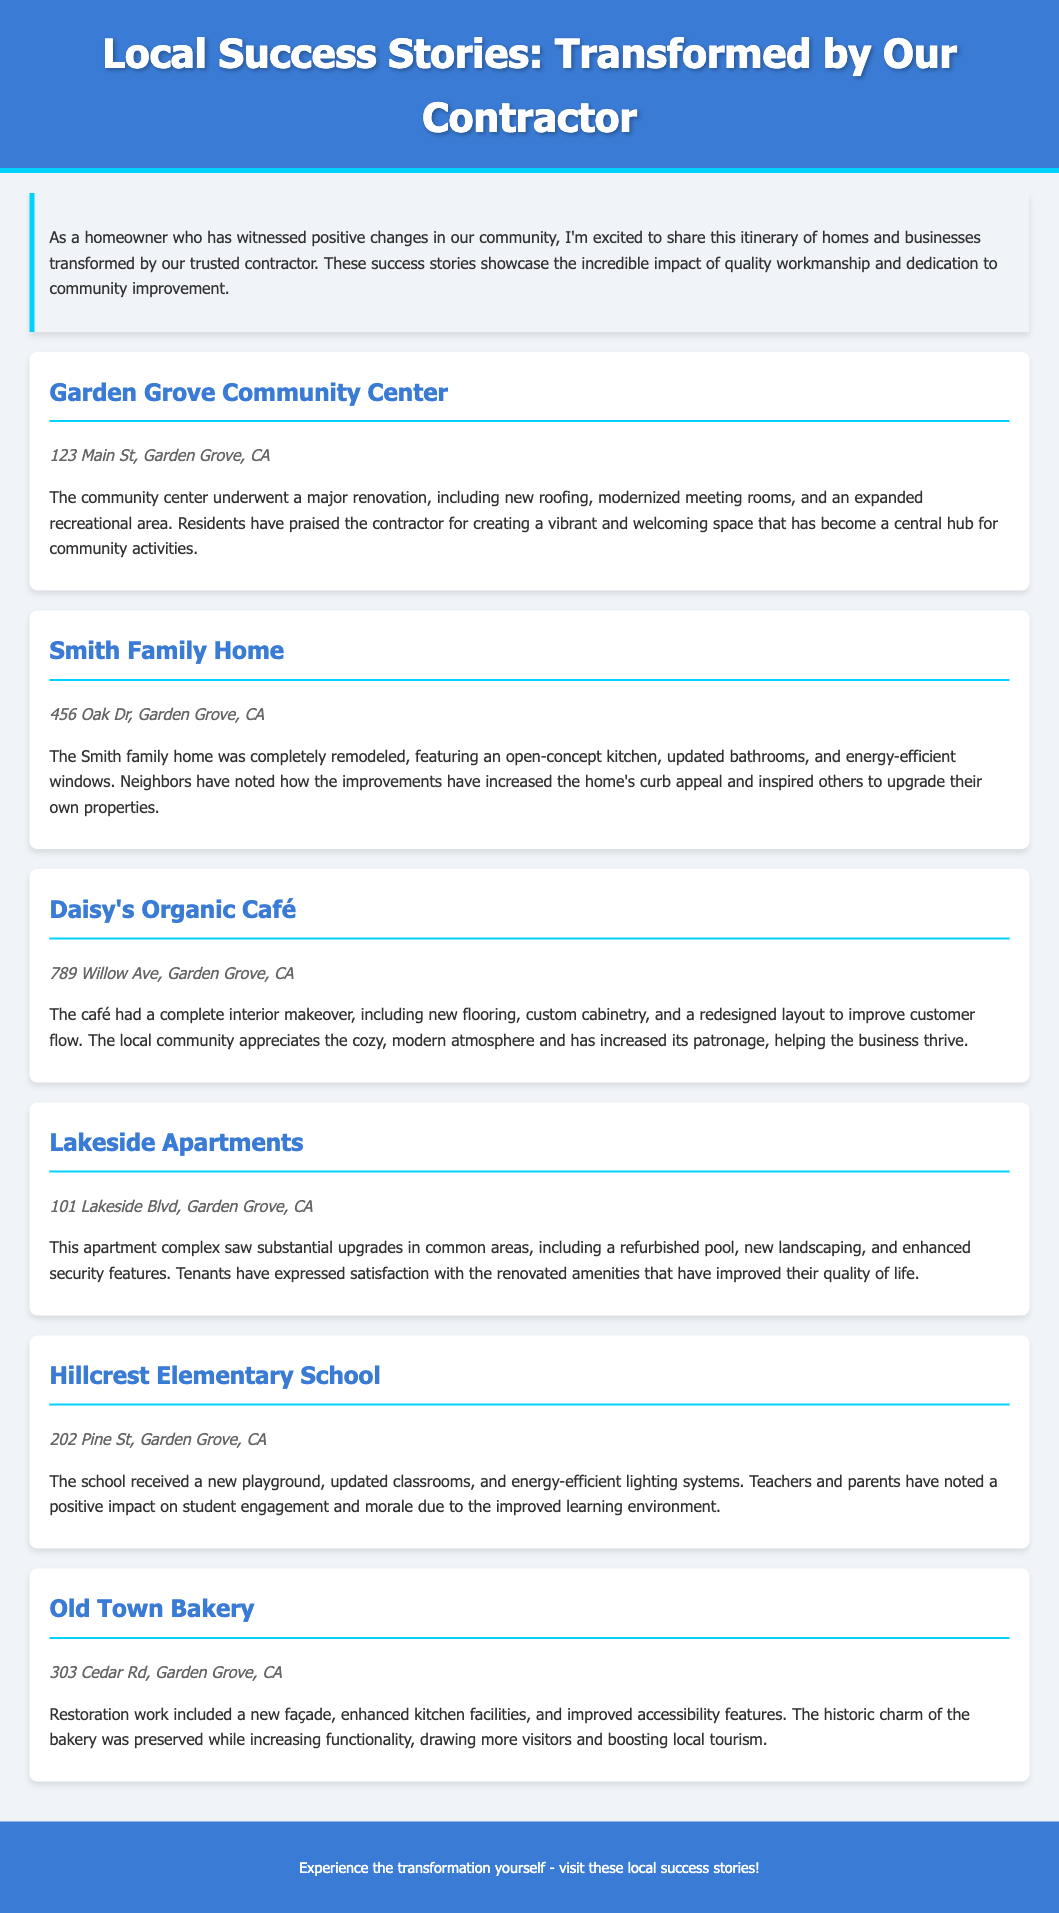What are the listed locations for the success stories? The document lists several locations, including the Garden Grove Community Center, Smith Family Home, Daisy's Organic Café, Lakeside Apartments, Hillcrest Elementary School, and Old Town Bakery.
Answer: Garden Grove Community Center, Smith Family Home, Daisy's Organic Café, Lakeside Apartments, Hillcrest Elementary School, Old Town Bakery What is the address of the Smith Family Home? The document provides the address as part of the description for the Smith Family Home.
Answer: 456 Oak Dr, Garden Grove, CA Which facility had a complete interior makeover? The document specifies that Daisy's Organic Café underwent a complete interior makeover.
Answer: Daisy's Organic Café What was added to Hillcrest Elementary School? The document mentions several improvements made to the school, specifically stating a new playground was added.
Answer: New playground How did the renovations at Lakeside Apartments affect the tenants? The document states that tenants expressed satisfaction due to the renovated amenities improving their quality of life.
Answer: Improved quality of life How many transformation sites are listed in the itinerary? The document provides a total number of transformation sites included in the itinerary, which is six.
Answer: Six 